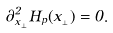<formula> <loc_0><loc_0><loc_500><loc_500>\partial _ { x _ { _ { \perp } } } ^ { 2 } H _ { p } ( x _ { _ { \perp } } ) = 0 .</formula> 